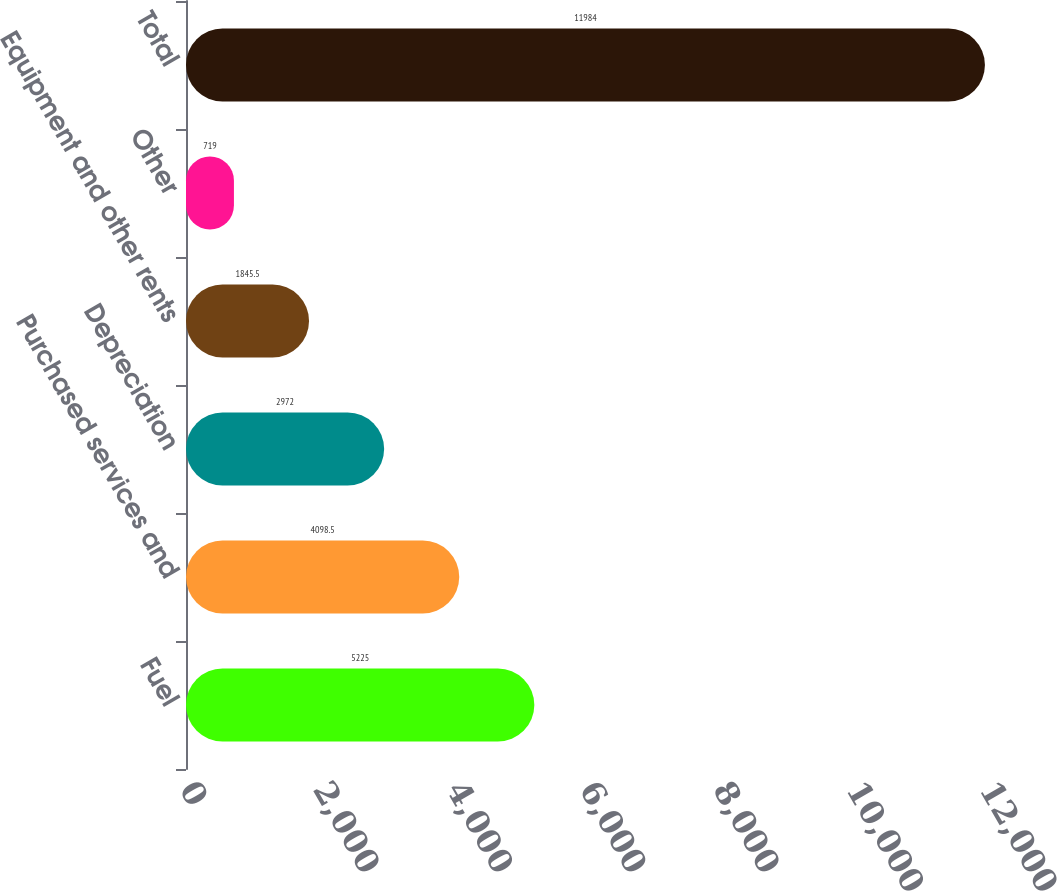Convert chart. <chart><loc_0><loc_0><loc_500><loc_500><bar_chart><fcel>Fuel<fcel>Purchased services and<fcel>Depreciation<fcel>Equipment and other rents<fcel>Other<fcel>Total<nl><fcel>5225<fcel>4098.5<fcel>2972<fcel>1845.5<fcel>719<fcel>11984<nl></chart> 